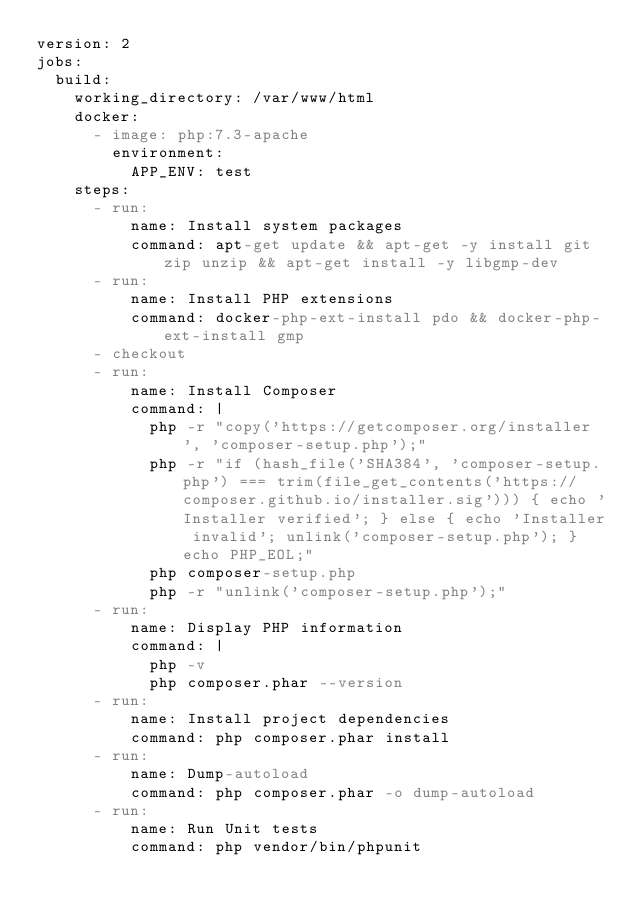Convert code to text. <code><loc_0><loc_0><loc_500><loc_500><_YAML_>version: 2
jobs:
  build:
    working_directory: /var/www/html
    docker:
      - image: php:7.3-apache
        environment:
          APP_ENV: test
    steps:
      - run:
          name: Install system packages
          command: apt-get update && apt-get -y install git zip unzip && apt-get install -y libgmp-dev
      - run:
          name: Install PHP extensions
          command: docker-php-ext-install pdo && docker-php-ext-install gmp
      - checkout
      - run:
          name: Install Composer
          command: |
            php -r "copy('https://getcomposer.org/installer', 'composer-setup.php');"
            php -r "if (hash_file('SHA384', 'composer-setup.php') === trim(file_get_contents('https://composer.github.io/installer.sig'))) { echo 'Installer verified'; } else { echo 'Installer invalid'; unlink('composer-setup.php'); } echo PHP_EOL;"
            php composer-setup.php
            php -r "unlink('composer-setup.php');"
      - run:
          name: Display PHP information
          command: |
            php -v
            php composer.phar --version
      - run:
          name: Install project dependencies
          command: php composer.phar install
      - run:
          name: Dump-autoload
          command: php composer.phar -o dump-autoload
      - run:
          name: Run Unit tests
          command: php vendor/bin/phpunit
</code> 